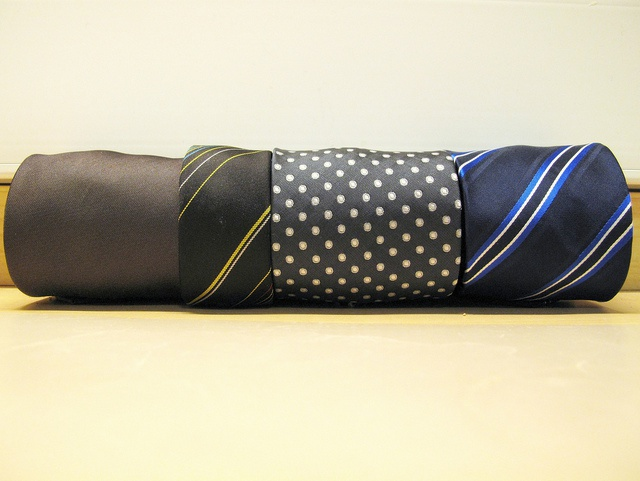Describe the objects in this image and their specific colors. I can see tie in beige, black, gray, darkgray, and ivory tones, tie in beige, black, gray, navy, and darkblue tones, tie in beige, black, and gray tones, and tie in beige, black, gray, darkgreen, and tan tones in this image. 